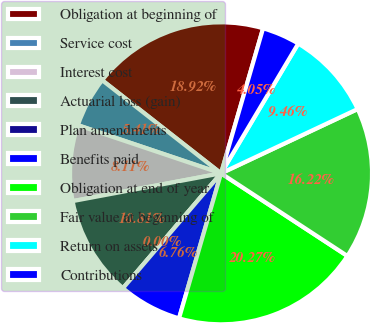Convert chart. <chart><loc_0><loc_0><loc_500><loc_500><pie_chart><fcel>Obligation at beginning of<fcel>Service cost<fcel>Interest cost<fcel>Actuarial loss (gain)<fcel>Plan amendments<fcel>Benefits paid<fcel>Obligation at end of year<fcel>Fair value at beginning of<fcel>Return on assets<fcel>Contributions<nl><fcel>18.92%<fcel>5.41%<fcel>8.11%<fcel>10.81%<fcel>0.0%<fcel>6.76%<fcel>20.27%<fcel>16.22%<fcel>9.46%<fcel>4.05%<nl></chart> 